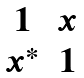<formula> <loc_0><loc_0><loc_500><loc_500>\begin{matrix} 1 & x \\ x ^ { * } & 1 \end{matrix}</formula> 